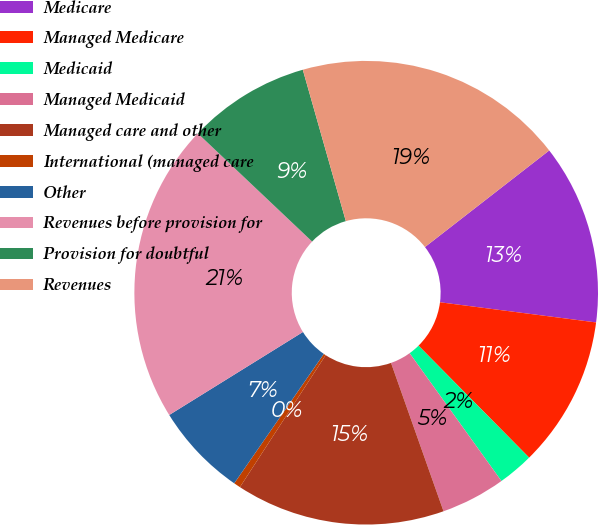Convert chart to OTSL. <chart><loc_0><loc_0><loc_500><loc_500><pie_chart><fcel>Medicare<fcel>Managed Medicare<fcel>Medicaid<fcel>Managed Medicaid<fcel>Managed care and other<fcel>International (managed care<fcel>Other<fcel>Revenues before provision for<fcel>Provision for doubtful<fcel>Revenues<nl><fcel>12.56%<fcel>10.55%<fcel>2.49%<fcel>4.5%<fcel>14.58%<fcel>0.47%<fcel>6.52%<fcel>20.9%<fcel>8.53%<fcel>18.89%<nl></chart> 